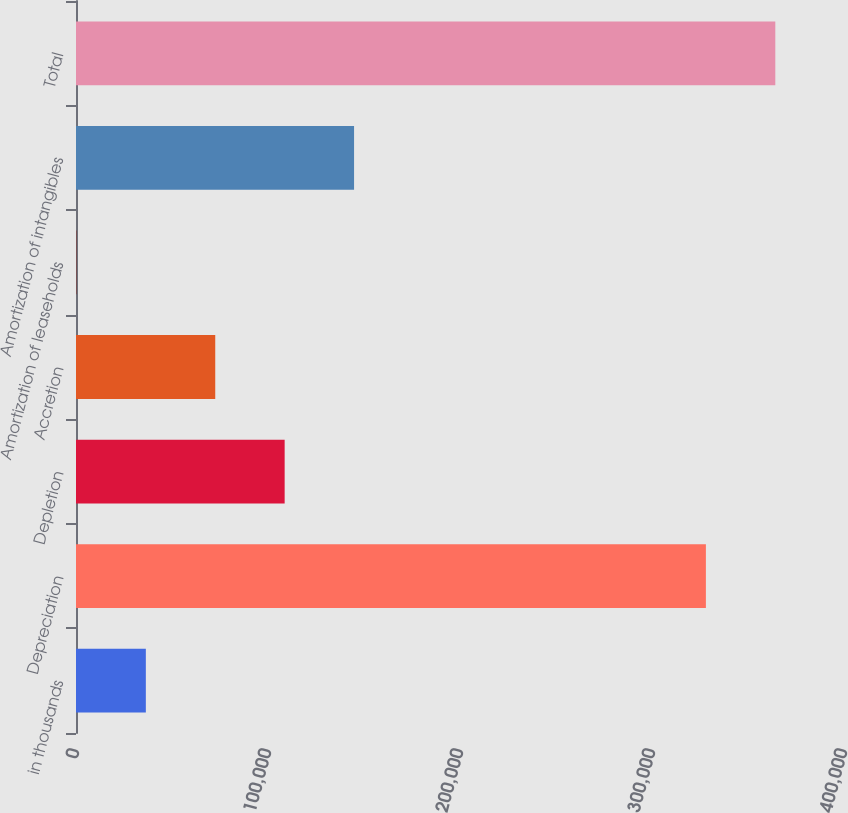Convert chart. <chart><loc_0><loc_0><loc_500><loc_500><bar_chart><fcel>in thousands<fcel>Depreciation<fcel>Depletion<fcel>Accretion<fcel>Amortization of leaseholds<fcel>Amortization of intangibles<fcel>Total<nl><fcel>36374.4<fcel>328072<fcel>108673<fcel>72523.8<fcel>225<fcel>144823<fcel>364221<nl></chart> 